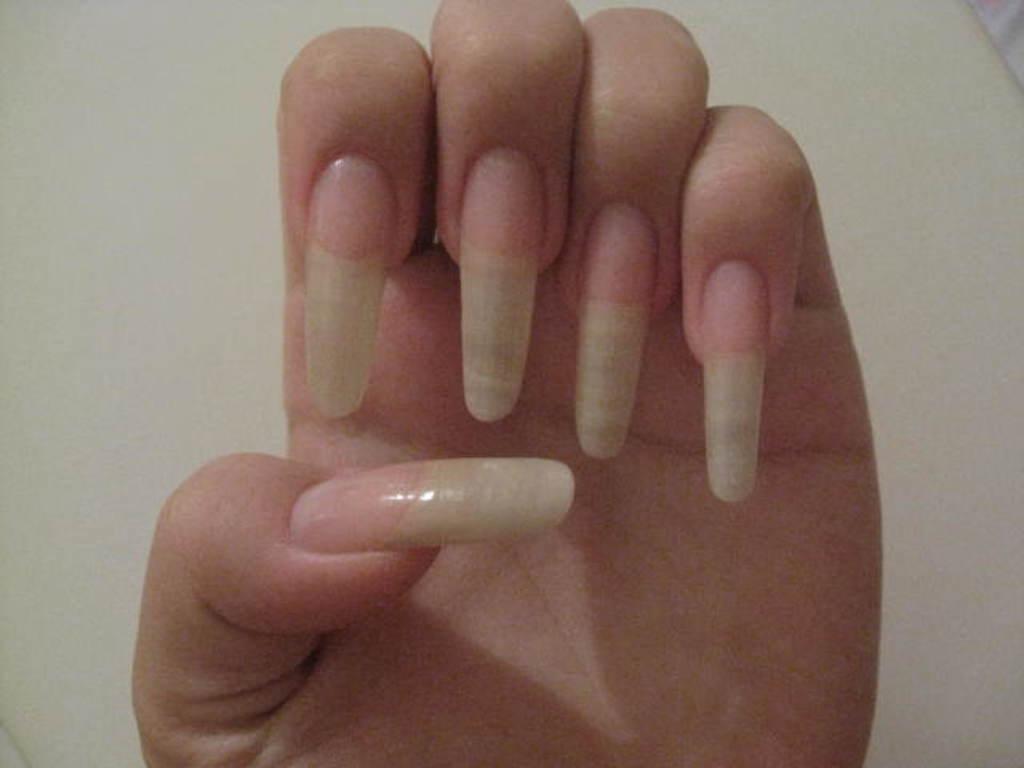Please provide a concise description of this image. In this picture we can see a person hand with nails and behind the hand there is a white background. 